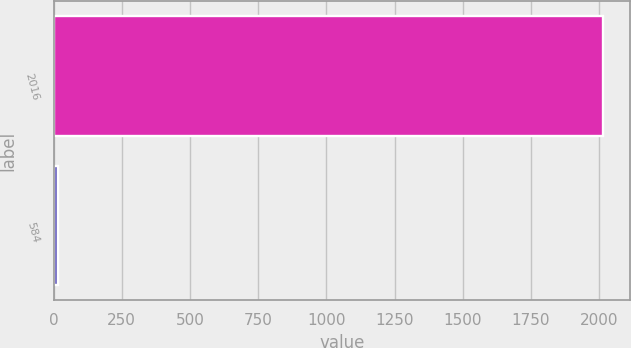Convert chart to OTSL. <chart><loc_0><loc_0><loc_500><loc_500><bar_chart><fcel>2016<fcel>584<nl><fcel>2014<fcel>17.8<nl></chart> 